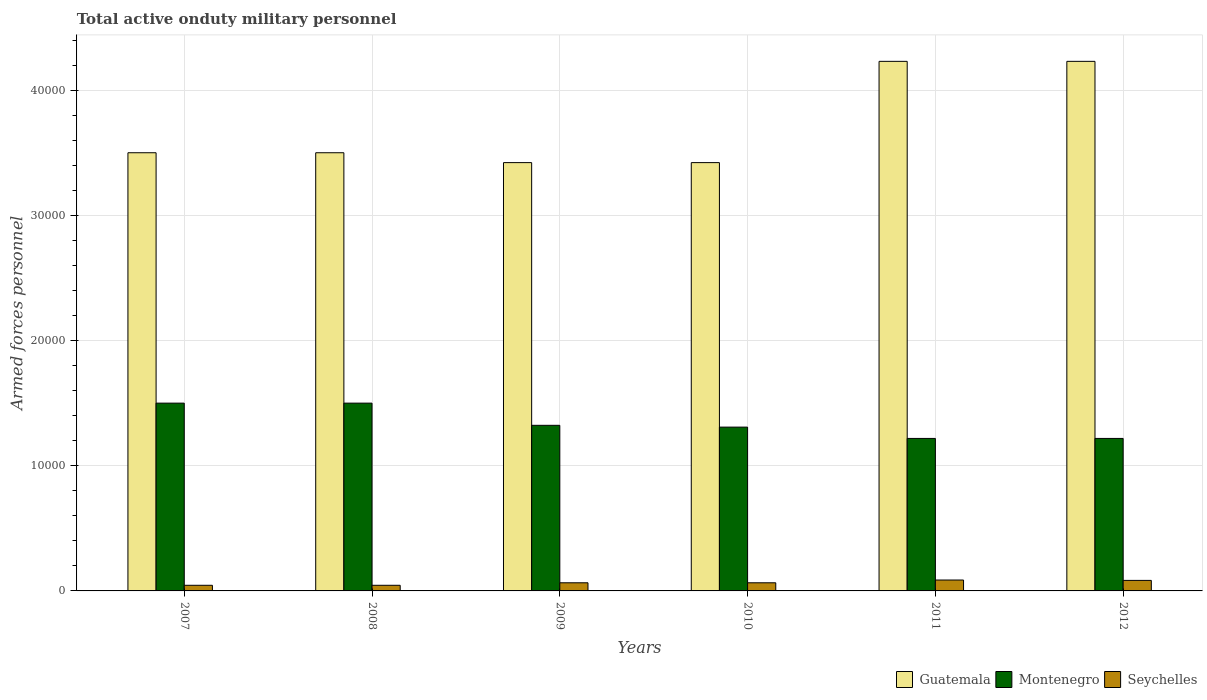How many groups of bars are there?
Make the answer very short. 6. How many bars are there on the 2nd tick from the right?
Provide a short and direct response. 3. What is the number of armed forces personnel in Guatemala in 2010?
Give a very brief answer. 3.42e+04. Across all years, what is the maximum number of armed forces personnel in Seychelles?
Your answer should be compact. 870. Across all years, what is the minimum number of armed forces personnel in Montenegro?
Offer a very short reply. 1.22e+04. In which year was the number of armed forces personnel in Guatemala minimum?
Offer a very short reply. 2009. What is the total number of armed forces personnel in Montenegro in the graph?
Your answer should be compact. 8.07e+04. What is the difference between the number of armed forces personnel in Seychelles in 2010 and that in 2011?
Give a very brief answer. -220. What is the difference between the number of armed forces personnel in Guatemala in 2007 and the number of armed forces personnel in Seychelles in 2008?
Provide a short and direct response. 3.46e+04. What is the average number of armed forces personnel in Seychelles per year?
Your response must be concise. 651.67. In the year 2012, what is the difference between the number of armed forces personnel in Montenegro and number of armed forces personnel in Seychelles?
Give a very brief answer. 1.13e+04. In how many years, is the number of armed forces personnel in Guatemala greater than 22000?
Your answer should be very brief. 6. What is the ratio of the number of armed forces personnel in Guatemala in 2008 to that in 2011?
Keep it short and to the point. 0.83. Is the difference between the number of armed forces personnel in Montenegro in 2007 and 2012 greater than the difference between the number of armed forces personnel in Seychelles in 2007 and 2012?
Your answer should be very brief. Yes. What is the difference between the highest and the lowest number of armed forces personnel in Seychelles?
Make the answer very short. 420. What does the 2nd bar from the left in 2008 represents?
Ensure brevity in your answer.  Montenegro. What does the 2nd bar from the right in 2010 represents?
Make the answer very short. Montenegro. Is it the case that in every year, the sum of the number of armed forces personnel in Montenegro and number of armed forces personnel in Guatemala is greater than the number of armed forces personnel in Seychelles?
Keep it short and to the point. Yes. How many bars are there?
Provide a short and direct response. 18. Are all the bars in the graph horizontal?
Offer a terse response. No. Are the values on the major ticks of Y-axis written in scientific E-notation?
Make the answer very short. No. Does the graph contain any zero values?
Provide a succinct answer. No. How many legend labels are there?
Ensure brevity in your answer.  3. What is the title of the graph?
Your answer should be compact. Total active onduty military personnel. What is the label or title of the X-axis?
Keep it short and to the point. Years. What is the label or title of the Y-axis?
Your answer should be compact. Armed forces personnel. What is the Armed forces personnel of Guatemala in 2007?
Provide a succinct answer. 3.50e+04. What is the Armed forces personnel of Montenegro in 2007?
Your answer should be compact. 1.50e+04. What is the Armed forces personnel in Seychelles in 2007?
Your answer should be very brief. 450. What is the Armed forces personnel in Guatemala in 2008?
Your answer should be very brief. 3.50e+04. What is the Armed forces personnel in Montenegro in 2008?
Offer a terse response. 1.50e+04. What is the Armed forces personnel in Seychelles in 2008?
Keep it short and to the point. 450. What is the Armed forces personnel of Guatemala in 2009?
Your answer should be very brief. 3.42e+04. What is the Armed forces personnel of Montenegro in 2009?
Provide a short and direct response. 1.32e+04. What is the Armed forces personnel in Seychelles in 2009?
Your answer should be compact. 650. What is the Armed forces personnel in Guatemala in 2010?
Provide a succinct answer. 3.42e+04. What is the Armed forces personnel of Montenegro in 2010?
Give a very brief answer. 1.31e+04. What is the Armed forces personnel in Seychelles in 2010?
Provide a short and direct response. 650. What is the Armed forces personnel of Guatemala in 2011?
Make the answer very short. 4.23e+04. What is the Armed forces personnel of Montenegro in 2011?
Your response must be concise. 1.22e+04. What is the Armed forces personnel in Seychelles in 2011?
Provide a short and direct response. 870. What is the Armed forces personnel of Guatemala in 2012?
Keep it short and to the point. 4.23e+04. What is the Armed forces personnel of Montenegro in 2012?
Provide a succinct answer. 1.22e+04. What is the Armed forces personnel in Seychelles in 2012?
Your response must be concise. 840. Across all years, what is the maximum Armed forces personnel in Guatemala?
Keep it short and to the point. 4.23e+04. Across all years, what is the maximum Armed forces personnel of Montenegro?
Your answer should be compact. 1.50e+04. Across all years, what is the maximum Armed forces personnel of Seychelles?
Keep it short and to the point. 870. Across all years, what is the minimum Armed forces personnel in Guatemala?
Offer a very short reply. 3.42e+04. Across all years, what is the minimum Armed forces personnel in Montenegro?
Your answer should be very brief. 1.22e+04. Across all years, what is the minimum Armed forces personnel in Seychelles?
Your answer should be very brief. 450. What is the total Armed forces personnel in Guatemala in the graph?
Provide a short and direct response. 2.23e+05. What is the total Armed forces personnel of Montenegro in the graph?
Provide a succinct answer. 8.07e+04. What is the total Armed forces personnel of Seychelles in the graph?
Your answer should be compact. 3910. What is the difference between the Armed forces personnel in Montenegro in 2007 and that in 2008?
Keep it short and to the point. 0. What is the difference between the Armed forces personnel in Guatemala in 2007 and that in 2009?
Offer a very short reply. 788. What is the difference between the Armed forces personnel of Montenegro in 2007 and that in 2009?
Keep it short and to the point. 1773. What is the difference between the Armed forces personnel in Seychelles in 2007 and that in 2009?
Make the answer very short. -200. What is the difference between the Armed forces personnel in Guatemala in 2007 and that in 2010?
Offer a very short reply. 788. What is the difference between the Armed forces personnel of Montenegro in 2007 and that in 2010?
Offer a terse response. 1916. What is the difference between the Armed forces personnel of Seychelles in 2007 and that in 2010?
Make the answer very short. -200. What is the difference between the Armed forces personnel of Guatemala in 2007 and that in 2011?
Provide a succinct answer. -7300. What is the difference between the Armed forces personnel of Montenegro in 2007 and that in 2011?
Your answer should be compact. 2820. What is the difference between the Armed forces personnel of Seychelles in 2007 and that in 2011?
Offer a very short reply. -420. What is the difference between the Armed forces personnel of Guatemala in 2007 and that in 2012?
Make the answer very short. -7300. What is the difference between the Armed forces personnel of Montenegro in 2007 and that in 2012?
Ensure brevity in your answer.  2820. What is the difference between the Armed forces personnel of Seychelles in 2007 and that in 2012?
Your answer should be compact. -390. What is the difference between the Armed forces personnel of Guatemala in 2008 and that in 2009?
Give a very brief answer. 788. What is the difference between the Armed forces personnel of Montenegro in 2008 and that in 2009?
Offer a very short reply. 1773. What is the difference between the Armed forces personnel of Seychelles in 2008 and that in 2009?
Give a very brief answer. -200. What is the difference between the Armed forces personnel of Guatemala in 2008 and that in 2010?
Make the answer very short. 788. What is the difference between the Armed forces personnel in Montenegro in 2008 and that in 2010?
Offer a terse response. 1916. What is the difference between the Armed forces personnel in Seychelles in 2008 and that in 2010?
Offer a terse response. -200. What is the difference between the Armed forces personnel in Guatemala in 2008 and that in 2011?
Ensure brevity in your answer.  -7300. What is the difference between the Armed forces personnel in Montenegro in 2008 and that in 2011?
Offer a very short reply. 2820. What is the difference between the Armed forces personnel of Seychelles in 2008 and that in 2011?
Provide a short and direct response. -420. What is the difference between the Armed forces personnel of Guatemala in 2008 and that in 2012?
Make the answer very short. -7300. What is the difference between the Armed forces personnel in Montenegro in 2008 and that in 2012?
Offer a terse response. 2820. What is the difference between the Armed forces personnel in Seychelles in 2008 and that in 2012?
Your answer should be compact. -390. What is the difference between the Armed forces personnel of Guatemala in 2009 and that in 2010?
Your response must be concise. 0. What is the difference between the Armed forces personnel of Montenegro in 2009 and that in 2010?
Keep it short and to the point. 143. What is the difference between the Armed forces personnel in Guatemala in 2009 and that in 2011?
Ensure brevity in your answer.  -8088. What is the difference between the Armed forces personnel in Montenegro in 2009 and that in 2011?
Keep it short and to the point. 1047. What is the difference between the Armed forces personnel of Seychelles in 2009 and that in 2011?
Ensure brevity in your answer.  -220. What is the difference between the Armed forces personnel in Guatemala in 2009 and that in 2012?
Offer a very short reply. -8088. What is the difference between the Armed forces personnel in Montenegro in 2009 and that in 2012?
Provide a short and direct response. 1047. What is the difference between the Armed forces personnel of Seychelles in 2009 and that in 2012?
Your answer should be very brief. -190. What is the difference between the Armed forces personnel of Guatemala in 2010 and that in 2011?
Keep it short and to the point. -8088. What is the difference between the Armed forces personnel of Montenegro in 2010 and that in 2011?
Offer a terse response. 904. What is the difference between the Armed forces personnel in Seychelles in 2010 and that in 2011?
Offer a very short reply. -220. What is the difference between the Armed forces personnel of Guatemala in 2010 and that in 2012?
Your answer should be very brief. -8088. What is the difference between the Armed forces personnel of Montenegro in 2010 and that in 2012?
Give a very brief answer. 904. What is the difference between the Armed forces personnel in Seychelles in 2010 and that in 2012?
Your response must be concise. -190. What is the difference between the Armed forces personnel of Montenegro in 2011 and that in 2012?
Keep it short and to the point. 0. What is the difference between the Armed forces personnel in Guatemala in 2007 and the Armed forces personnel in Montenegro in 2008?
Your answer should be very brief. 2.00e+04. What is the difference between the Armed forces personnel of Guatemala in 2007 and the Armed forces personnel of Seychelles in 2008?
Your answer should be very brief. 3.46e+04. What is the difference between the Armed forces personnel in Montenegro in 2007 and the Armed forces personnel in Seychelles in 2008?
Offer a very short reply. 1.46e+04. What is the difference between the Armed forces personnel of Guatemala in 2007 and the Armed forces personnel of Montenegro in 2009?
Your answer should be compact. 2.18e+04. What is the difference between the Armed forces personnel of Guatemala in 2007 and the Armed forces personnel of Seychelles in 2009?
Provide a succinct answer. 3.44e+04. What is the difference between the Armed forces personnel in Montenegro in 2007 and the Armed forces personnel in Seychelles in 2009?
Ensure brevity in your answer.  1.44e+04. What is the difference between the Armed forces personnel of Guatemala in 2007 and the Armed forces personnel of Montenegro in 2010?
Make the answer very short. 2.19e+04. What is the difference between the Armed forces personnel of Guatemala in 2007 and the Armed forces personnel of Seychelles in 2010?
Provide a succinct answer. 3.44e+04. What is the difference between the Armed forces personnel in Montenegro in 2007 and the Armed forces personnel in Seychelles in 2010?
Ensure brevity in your answer.  1.44e+04. What is the difference between the Armed forces personnel of Guatemala in 2007 and the Armed forces personnel of Montenegro in 2011?
Make the answer very short. 2.28e+04. What is the difference between the Armed forces personnel in Guatemala in 2007 and the Armed forces personnel in Seychelles in 2011?
Give a very brief answer. 3.41e+04. What is the difference between the Armed forces personnel of Montenegro in 2007 and the Armed forces personnel of Seychelles in 2011?
Provide a short and direct response. 1.41e+04. What is the difference between the Armed forces personnel in Guatemala in 2007 and the Armed forces personnel in Montenegro in 2012?
Offer a terse response. 2.28e+04. What is the difference between the Armed forces personnel of Guatemala in 2007 and the Armed forces personnel of Seychelles in 2012?
Keep it short and to the point. 3.42e+04. What is the difference between the Armed forces personnel of Montenegro in 2007 and the Armed forces personnel of Seychelles in 2012?
Your answer should be compact. 1.42e+04. What is the difference between the Armed forces personnel of Guatemala in 2008 and the Armed forces personnel of Montenegro in 2009?
Provide a succinct answer. 2.18e+04. What is the difference between the Armed forces personnel of Guatemala in 2008 and the Armed forces personnel of Seychelles in 2009?
Your answer should be very brief. 3.44e+04. What is the difference between the Armed forces personnel in Montenegro in 2008 and the Armed forces personnel in Seychelles in 2009?
Offer a very short reply. 1.44e+04. What is the difference between the Armed forces personnel of Guatemala in 2008 and the Armed forces personnel of Montenegro in 2010?
Give a very brief answer. 2.19e+04. What is the difference between the Armed forces personnel of Guatemala in 2008 and the Armed forces personnel of Seychelles in 2010?
Offer a terse response. 3.44e+04. What is the difference between the Armed forces personnel in Montenegro in 2008 and the Armed forces personnel in Seychelles in 2010?
Offer a very short reply. 1.44e+04. What is the difference between the Armed forces personnel of Guatemala in 2008 and the Armed forces personnel of Montenegro in 2011?
Your answer should be very brief. 2.28e+04. What is the difference between the Armed forces personnel in Guatemala in 2008 and the Armed forces personnel in Seychelles in 2011?
Your answer should be very brief. 3.41e+04. What is the difference between the Armed forces personnel of Montenegro in 2008 and the Armed forces personnel of Seychelles in 2011?
Provide a short and direct response. 1.41e+04. What is the difference between the Armed forces personnel in Guatemala in 2008 and the Armed forces personnel in Montenegro in 2012?
Make the answer very short. 2.28e+04. What is the difference between the Armed forces personnel in Guatemala in 2008 and the Armed forces personnel in Seychelles in 2012?
Provide a succinct answer. 3.42e+04. What is the difference between the Armed forces personnel in Montenegro in 2008 and the Armed forces personnel in Seychelles in 2012?
Keep it short and to the point. 1.42e+04. What is the difference between the Armed forces personnel of Guatemala in 2009 and the Armed forces personnel of Montenegro in 2010?
Ensure brevity in your answer.  2.11e+04. What is the difference between the Armed forces personnel in Guatemala in 2009 and the Armed forces personnel in Seychelles in 2010?
Your answer should be very brief. 3.36e+04. What is the difference between the Armed forces personnel in Montenegro in 2009 and the Armed forces personnel in Seychelles in 2010?
Offer a terse response. 1.26e+04. What is the difference between the Armed forces personnel of Guatemala in 2009 and the Armed forces personnel of Montenegro in 2011?
Your answer should be compact. 2.20e+04. What is the difference between the Armed forces personnel of Guatemala in 2009 and the Armed forces personnel of Seychelles in 2011?
Your answer should be very brief. 3.33e+04. What is the difference between the Armed forces personnel of Montenegro in 2009 and the Armed forces personnel of Seychelles in 2011?
Provide a succinct answer. 1.24e+04. What is the difference between the Armed forces personnel in Guatemala in 2009 and the Armed forces personnel in Montenegro in 2012?
Offer a very short reply. 2.20e+04. What is the difference between the Armed forces personnel of Guatemala in 2009 and the Armed forces personnel of Seychelles in 2012?
Your answer should be very brief. 3.34e+04. What is the difference between the Armed forces personnel in Montenegro in 2009 and the Armed forces personnel in Seychelles in 2012?
Keep it short and to the point. 1.24e+04. What is the difference between the Armed forces personnel in Guatemala in 2010 and the Armed forces personnel in Montenegro in 2011?
Offer a terse response. 2.20e+04. What is the difference between the Armed forces personnel of Guatemala in 2010 and the Armed forces personnel of Seychelles in 2011?
Offer a terse response. 3.33e+04. What is the difference between the Armed forces personnel in Montenegro in 2010 and the Armed forces personnel in Seychelles in 2011?
Offer a very short reply. 1.22e+04. What is the difference between the Armed forces personnel in Guatemala in 2010 and the Armed forces personnel in Montenegro in 2012?
Your answer should be compact. 2.20e+04. What is the difference between the Armed forces personnel of Guatemala in 2010 and the Armed forces personnel of Seychelles in 2012?
Provide a short and direct response. 3.34e+04. What is the difference between the Armed forces personnel in Montenegro in 2010 and the Armed forces personnel in Seychelles in 2012?
Offer a very short reply. 1.22e+04. What is the difference between the Armed forces personnel in Guatemala in 2011 and the Armed forces personnel in Montenegro in 2012?
Your answer should be compact. 3.01e+04. What is the difference between the Armed forces personnel in Guatemala in 2011 and the Armed forces personnel in Seychelles in 2012?
Your answer should be compact. 4.15e+04. What is the difference between the Armed forces personnel in Montenegro in 2011 and the Armed forces personnel in Seychelles in 2012?
Offer a very short reply. 1.13e+04. What is the average Armed forces personnel in Guatemala per year?
Provide a short and direct response. 3.72e+04. What is the average Armed forces personnel of Montenegro per year?
Ensure brevity in your answer.  1.34e+04. What is the average Armed forces personnel in Seychelles per year?
Ensure brevity in your answer.  651.67. In the year 2007, what is the difference between the Armed forces personnel of Guatemala and Armed forces personnel of Seychelles?
Your answer should be very brief. 3.46e+04. In the year 2007, what is the difference between the Armed forces personnel of Montenegro and Armed forces personnel of Seychelles?
Ensure brevity in your answer.  1.46e+04. In the year 2008, what is the difference between the Armed forces personnel in Guatemala and Armed forces personnel in Montenegro?
Make the answer very short. 2.00e+04. In the year 2008, what is the difference between the Armed forces personnel of Guatemala and Armed forces personnel of Seychelles?
Make the answer very short. 3.46e+04. In the year 2008, what is the difference between the Armed forces personnel in Montenegro and Armed forces personnel in Seychelles?
Your answer should be very brief. 1.46e+04. In the year 2009, what is the difference between the Armed forces personnel of Guatemala and Armed forces personnel of Montenegro?
Keep it short and to the point. 2.10e+04. In the year 2009, what is the difference between the Armed forces personnel in Guatemala and Armed forces personnel in Seychelles?
Provide a succinct answer. 3.36e+04. In the year 2009, what is the difference between the Armed forces personnel in Montenegro and Armed forces personnel in Seychelles?
Provide a succinct answer. 1.26e+04. In the year 2010, what is the difference between the Armed forces personnel of Guatemala and Armed forces personnel of Montenegro?
Your answer should be compact. 2.11e+04. In the year 2010, what is the difference between the Armed forces personnel of Guatemala and Armed forces personnel of Seychelles?
Offer a very short reply. 3.36e+04. In the year 2010, what is the difference between the Armed forces personnel in Montenegro and Armed forces personnel in Seychelles?
Your answer should be compact. 1.24e+04. In the year 2011, what is the difference between the Armed forces personnel of Guatemala and Armed forces personnel of Montenegro?
Your answer should be very brief. 3.01e+04. In the year 2011, what is the difference between the Armed forces personnel in Guatemala and Armed forces personnel in Seychelles?
Provide a succinct answer. 4.14e+04. In the year 2011, what is the difference between the Armed forces personnel of Montenegro and Armed forces personnel of Seychelles?
Your answer should be compact. 1.13e+04. In the year 2012, what is the difference between the Armed forces personnel in Guatemala and Armed forces personnel in Montenegro?
Offer a terse response. 3.01e+04. In the year 2012, what is the difference between the Armed forces personnel of Guatemala and Armed forces personnel of Seychelles?
Your answer should be very brief. 4.15e+04. In the year 2012, what is the difference between the Armed forces personnel in Montenegro and Armed forces personnel in Seychelles?
Your answer should be very brief. 1.13e+04. What is the ratio of the Armed forces personnel of Montenegro in 2007 to that in 2008?
Keep it short and to the point. 1. What is the ratio of the Armed forces personnel of Guatemala in 2007 to that in 2009?
Your response must be concise. 1.02. What is the ratio of the Armed forces personnel of Montenegro in 2007 to that in 2009?
Keep it short and to the point. 1.13. What is the ratio of the Armed forces personnel of Seychelles in 2007 to that in 2009?
Give a very brief answer. 0.69. What is the ratio of the Armed forces personnel of Montenegro in 2007 to that in 2010?
Your answer should be very brief. 1.15. What is the ratio of the Armed forces personnel in Seychelles in 2007 to that in 2010?
Provide a short and direct response. 0.69. What is the ratio of the Armed forces personnel of Guatemala in 2007 to that in 2011?
Provide a short and direct response. 0.83. What is the ratio of the Armed forces personnel of Montenegro in 2007 to that in 2011?
Keep it short and to the point. 1.23. What is the ratio of the Armed forces personnel of Seychelles in 2007 to that in 2011?
Provide a succinct answer. 0.52. What is the ratio of the Armed forces personnel in Guatemala in 2007 to that in 2012?
Your response must be concise. 0.83. What is the ratio of the Armed forces personnel of Montenegro in 2007 to that in 2012?
Provide a succinct answer. 1.23. What is the ratio of the Armed forces personnel in Seychelles in 2007 to that in 2012?
Your answer should be very brief. 0.54. What is the ratio of the Armed forces personnel in Guatemala in 2008 to that in 2009?
Your answer should be compact. 1.02. What is the ratio of the Armed forces personnel of Montenegro in 2008 to that in 2009?
Provide a short and direct response. 1.13. What is the ratio of the Armed forces personnel in Seychelles in 2008 to that in 2009?
Your answer should be compact. 0.69. What is the ratio of the Armed forces personnel of Montenegro in 2008 to that in 2010?
Ensure brevity in your answer.  1.15. What is the ratio of the Armed forces personnel of Seychelles in 2008 to that in 2010?
Your answer should be very brief. 0.69. What is the ratio of the Armed forces personnel in Guatemala in 2008 to that in 2011?
Provide a short and direct response. 0.83. What is the ratio of the Armed forces personnel in Montenegro in 2008 to that in 2011?
Your answer should be compact. 1.23. What is the ratio of the Armed forces personnel of Seychelles in 2008 to that in 2011?
Give a very brief answer. 0.52. What is the ratio of the Armed forces personnel in Guatemala in 2008 to that in 2012?
Provide a short and direct response. 0.83. What is the ratio of the Armed forces personnel in Montenegro in 2008 to that in 2012?
Make the answer very short. 1.23. What is the ratio of the Armed forces personnel of Seychelles in 2008 to that in 2012?
Your answer should be very brief. 0.54. What is the ratio of the Armed forces personnel in Guatemala in 2009 to that in 2010?
Provide a short and direct response. 1. What is the ratio of the Armed forces personnel in Montenegro in 2009 to that in 2010?
Your response must be concise. 1.01. What is the ratio of the Armed forces personnel of Guatemala in 2009 to that in 2011?
Offer a terse response. 0.81. What is the ratio of the Armed forces personnel of Montenegro in 2009 to that in 2011?
Give a very brief answer. 1.09. What is the ratio of the Armed forces personnel of Seychelles in 2009 to that in 2011?
Provide a succinct answer. 0.75. What is the ratio of the Armed forces personnel in Guatemala in 2009 to that in 2012?
Keep it short and to the point. 0.81. What is the ratio of the Armed forces personnel in Montenegro in 2009 to that in 2012?
Your response must be concise. 1.09. What is the ratio of the Armed forces personnel of Seychelles in 2009 to that in 2012?
Offer a terse response. 0.77. What is the ratio of the Armed forces personnel of Guatemala in 2010 to that in 2011?
Keep it short and to the point. 0.81. What is the ratio of the Armed forces personnel of Montenegro in 2010 to that in 2011?
Your response must be concise. 1.07. What is the ratio of the Armed forces personnel in Seychelles in 2010 to that in 2011?
Your answer should be compact. 0.75. What is the ratio of the Armed forces personnel in Guatemala in 2010 to that in 2012?
Keep it short and to the point. 0.81. What is the ratio of the Armed forces personnel in Montenegro in 2010 to that in 2012?
Offer a terse response. 1.07. What is the ratio of the Armed forces personnel in Seychelles in 2010 to that in 2012?
Your answer should be compact. 0.77. What is the ratio of the Armed forces personnel in Seychelles in 2011 to that in 2012?
Keep it short and to the point. 1.04. What is the difference between the highest and the second highest Armed forces personnel of Montenegro?
Ensure brevity in your answer.  0. What is the difference between the highest and the second highest Armed forces personnel in Seychelles?
Keep it short and to the point. 30. What is the difference between the highest and the lowest Armed forces personnel in Guatemala?
Offer a terse response. 8088. What is the difference between the highest and the lowest Armed forces personnel in Montenegro?
Give a very brief answer. 2820. What is the difference between the highest and the lowest Armed forces personnel in Seychelles?
Keep it short and to the point. 420. 